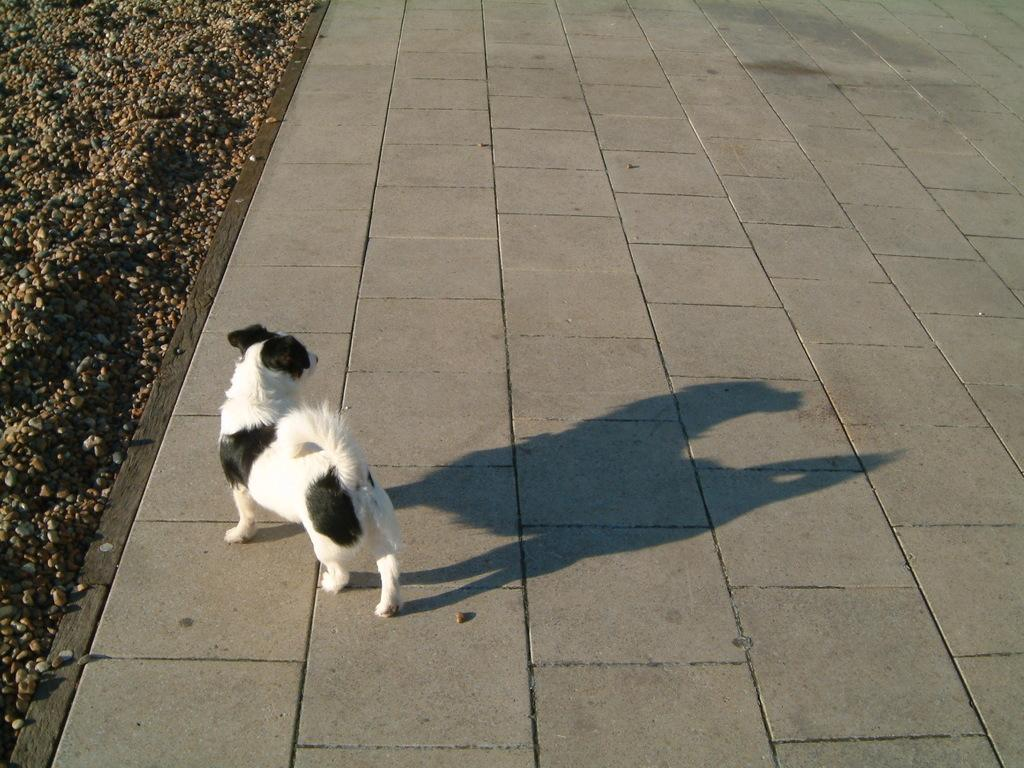What type of animal is in the image? There is a white dog in the image. What is the dog doing in the image? The dog is walking on a walkway. What can be seen on the left side of the image? There are stones visible on the left side of the image. How does the dog contribute to pollution in the image? The dog does not contribute to pollution in the image; there is no indication of pollution in the provided facts. 